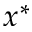<formula> <loc_0><loc_0><loc_500><loc_500>x ^ { * }</formula> 